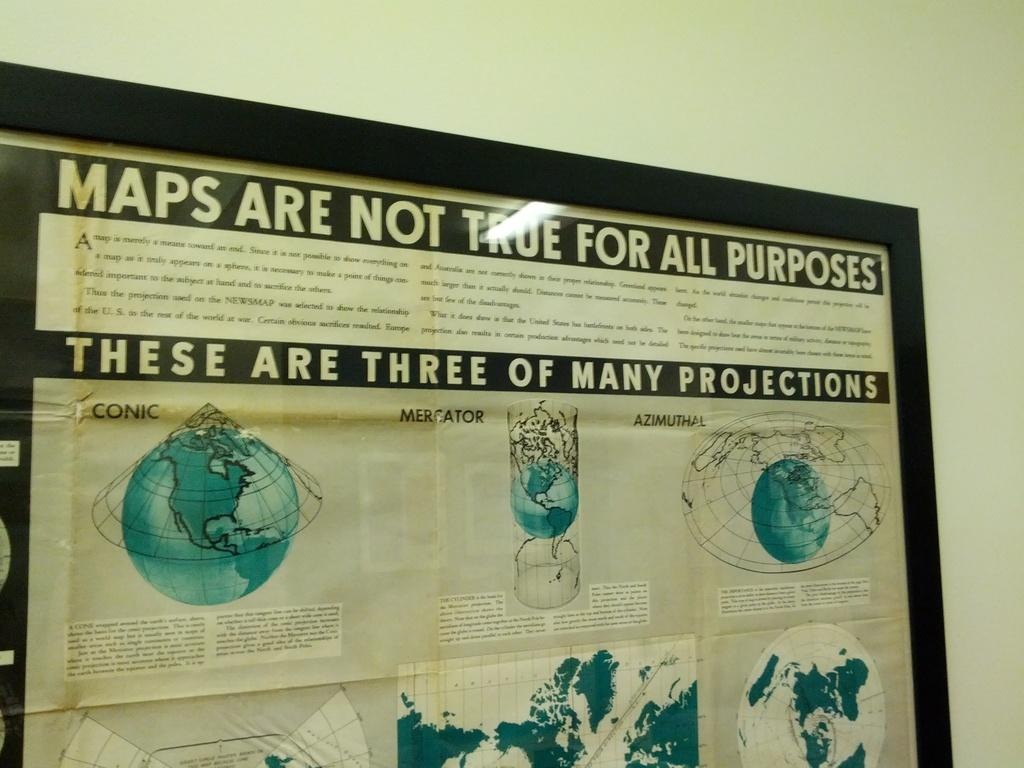<image>
Summarize the visual content of the image. A display of maps with the title maps are not true for all purposes. 